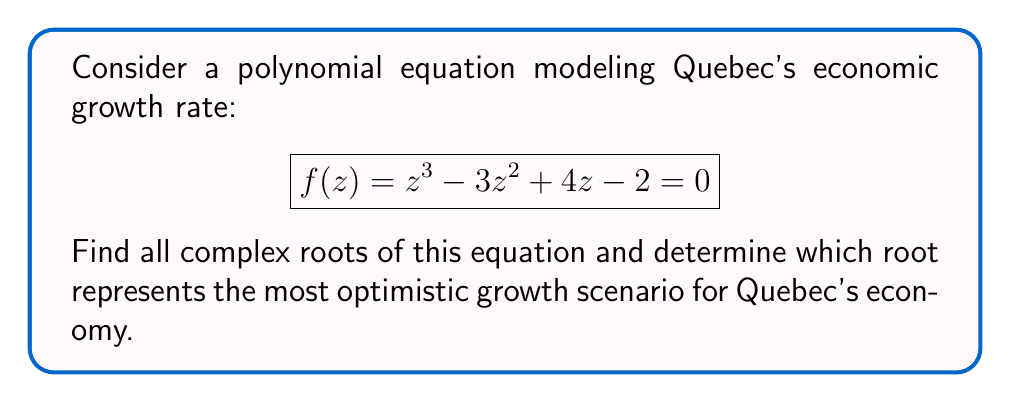Could you help me with this problem? To solve this problem, we'll follow these steps:

1) First, we need to find all complex roots of the equation $f(z) = z^3 - 3z^2 + 4z - 2 = 0$.

2) We can use the cubic formula, but it's complex. Instead, let's use the rational root theorem to find one root, then use polynomial long division to find the others.

3) Potential rational roots are factors of the constant term: $\pm 1, \pm 2$

4) Testing these, we find that $z = 1$ is a root.

5) Dividing $f(z)$ by $(z-1)$:

   $z^3 - 3z^2 + 4z - 2 = (z-1)(z^2 - 2z + 2)$

6) Now we need to solve $z^2 - 2z + 2 = 0$

7) Using the quadratic formula: $z = \frac{-b \pm \sqrt{b^2-4ac}}{2a}$

   $z = \frac{2 \pm \sqrt{4-8}}{2} = \frac{2 \pm \sqrt{-4}}{2} = \frac{2 \pm 2i}{2} = 1 \pm i$

8) Therefore, the three roots are:
   $z_1 = 1$
   $z_2 = 1 + i$
   $z_3 = 1 - i$

9) In the context of economic growth, the real part represents the actual growth rate, while the imaginary part could represent economic volatility or uncertainty.

10) The root with the largest real part and smallest absolute imaginary part would represent the most optimistic growth scenario.

11) In this case, $z_1 = 1$ has the largest real part and no imaginary part, making it the most optimistic scenario.
Answer: The complex roots are $z_1 = 1$, $z_2 = 1 + i$, and $z_3 = 1 - i$. The root representing the most optimistic growth scenario for Quebec's economy is $z_1 = 1$. 